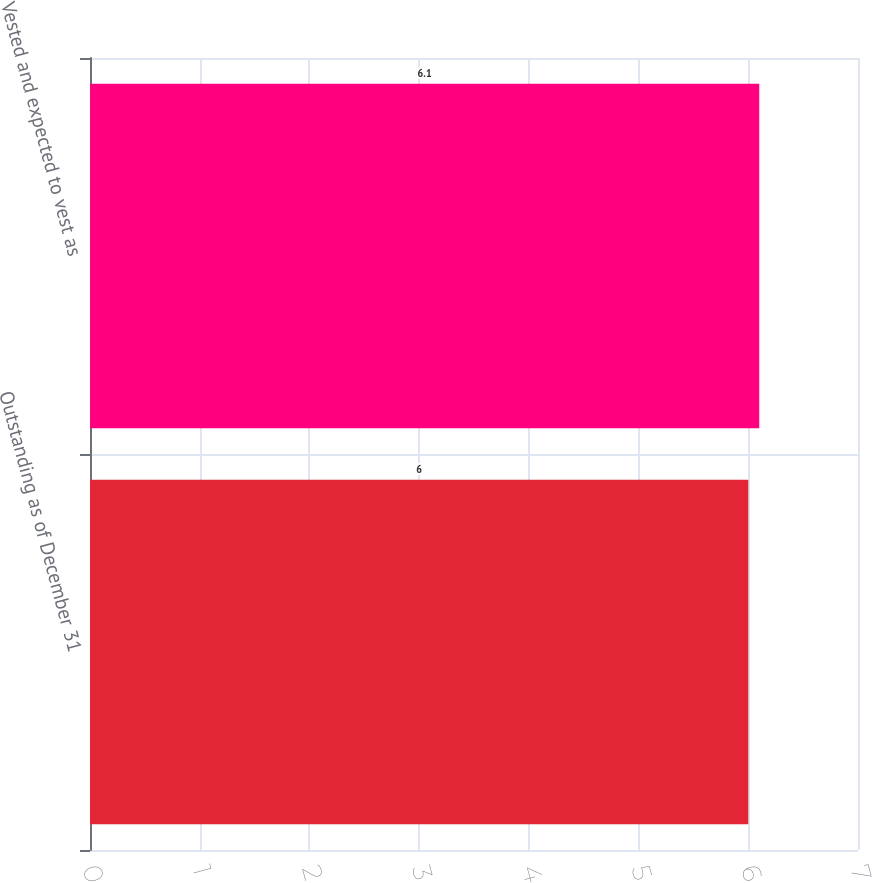Convert chart to OTSL. <chart><loc_0><loc_0><loc_500><loc_500><bar_chart><fcel>Outstanding as of December 31<fcel>Vested and expected to vest as<nl><fcel>6<fcel>6.1<nl></chart> 